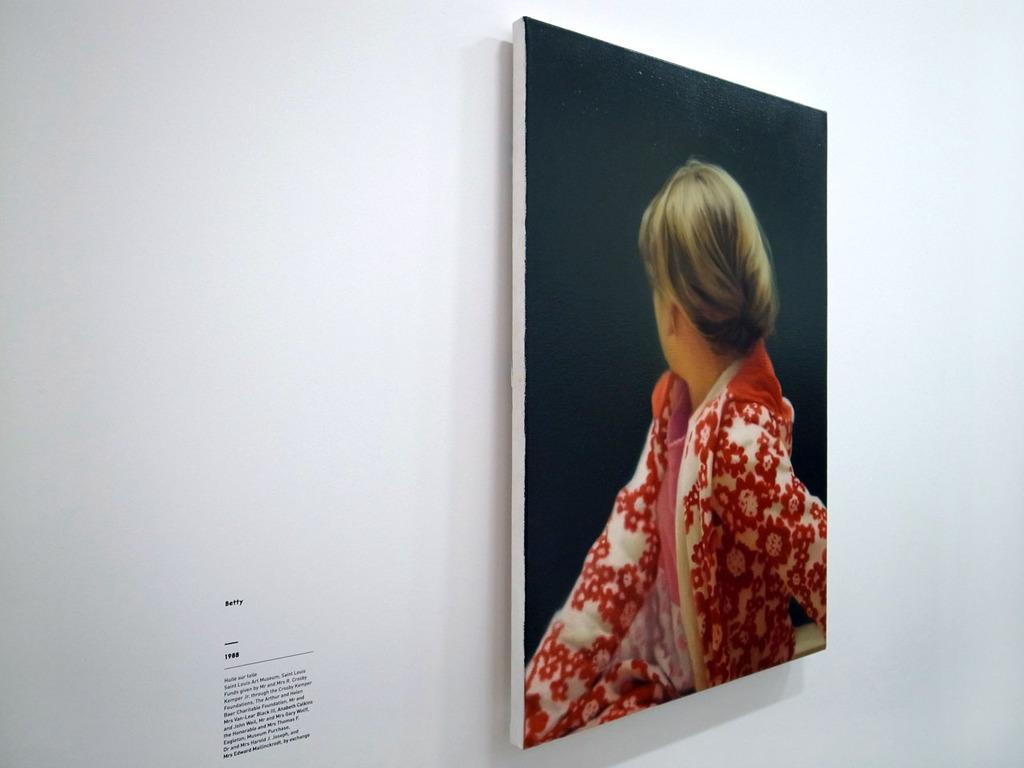What is attached to the wall in the image? There is a photo attached to a wall in the image. What can be seen on the wall near the photo? There is text on the wall on the left side of the photo. What type of cushion is the queen sitting on in the image? There is no queen or cushion present in the image; it only features a photo attached to a wall with text on the left side. 